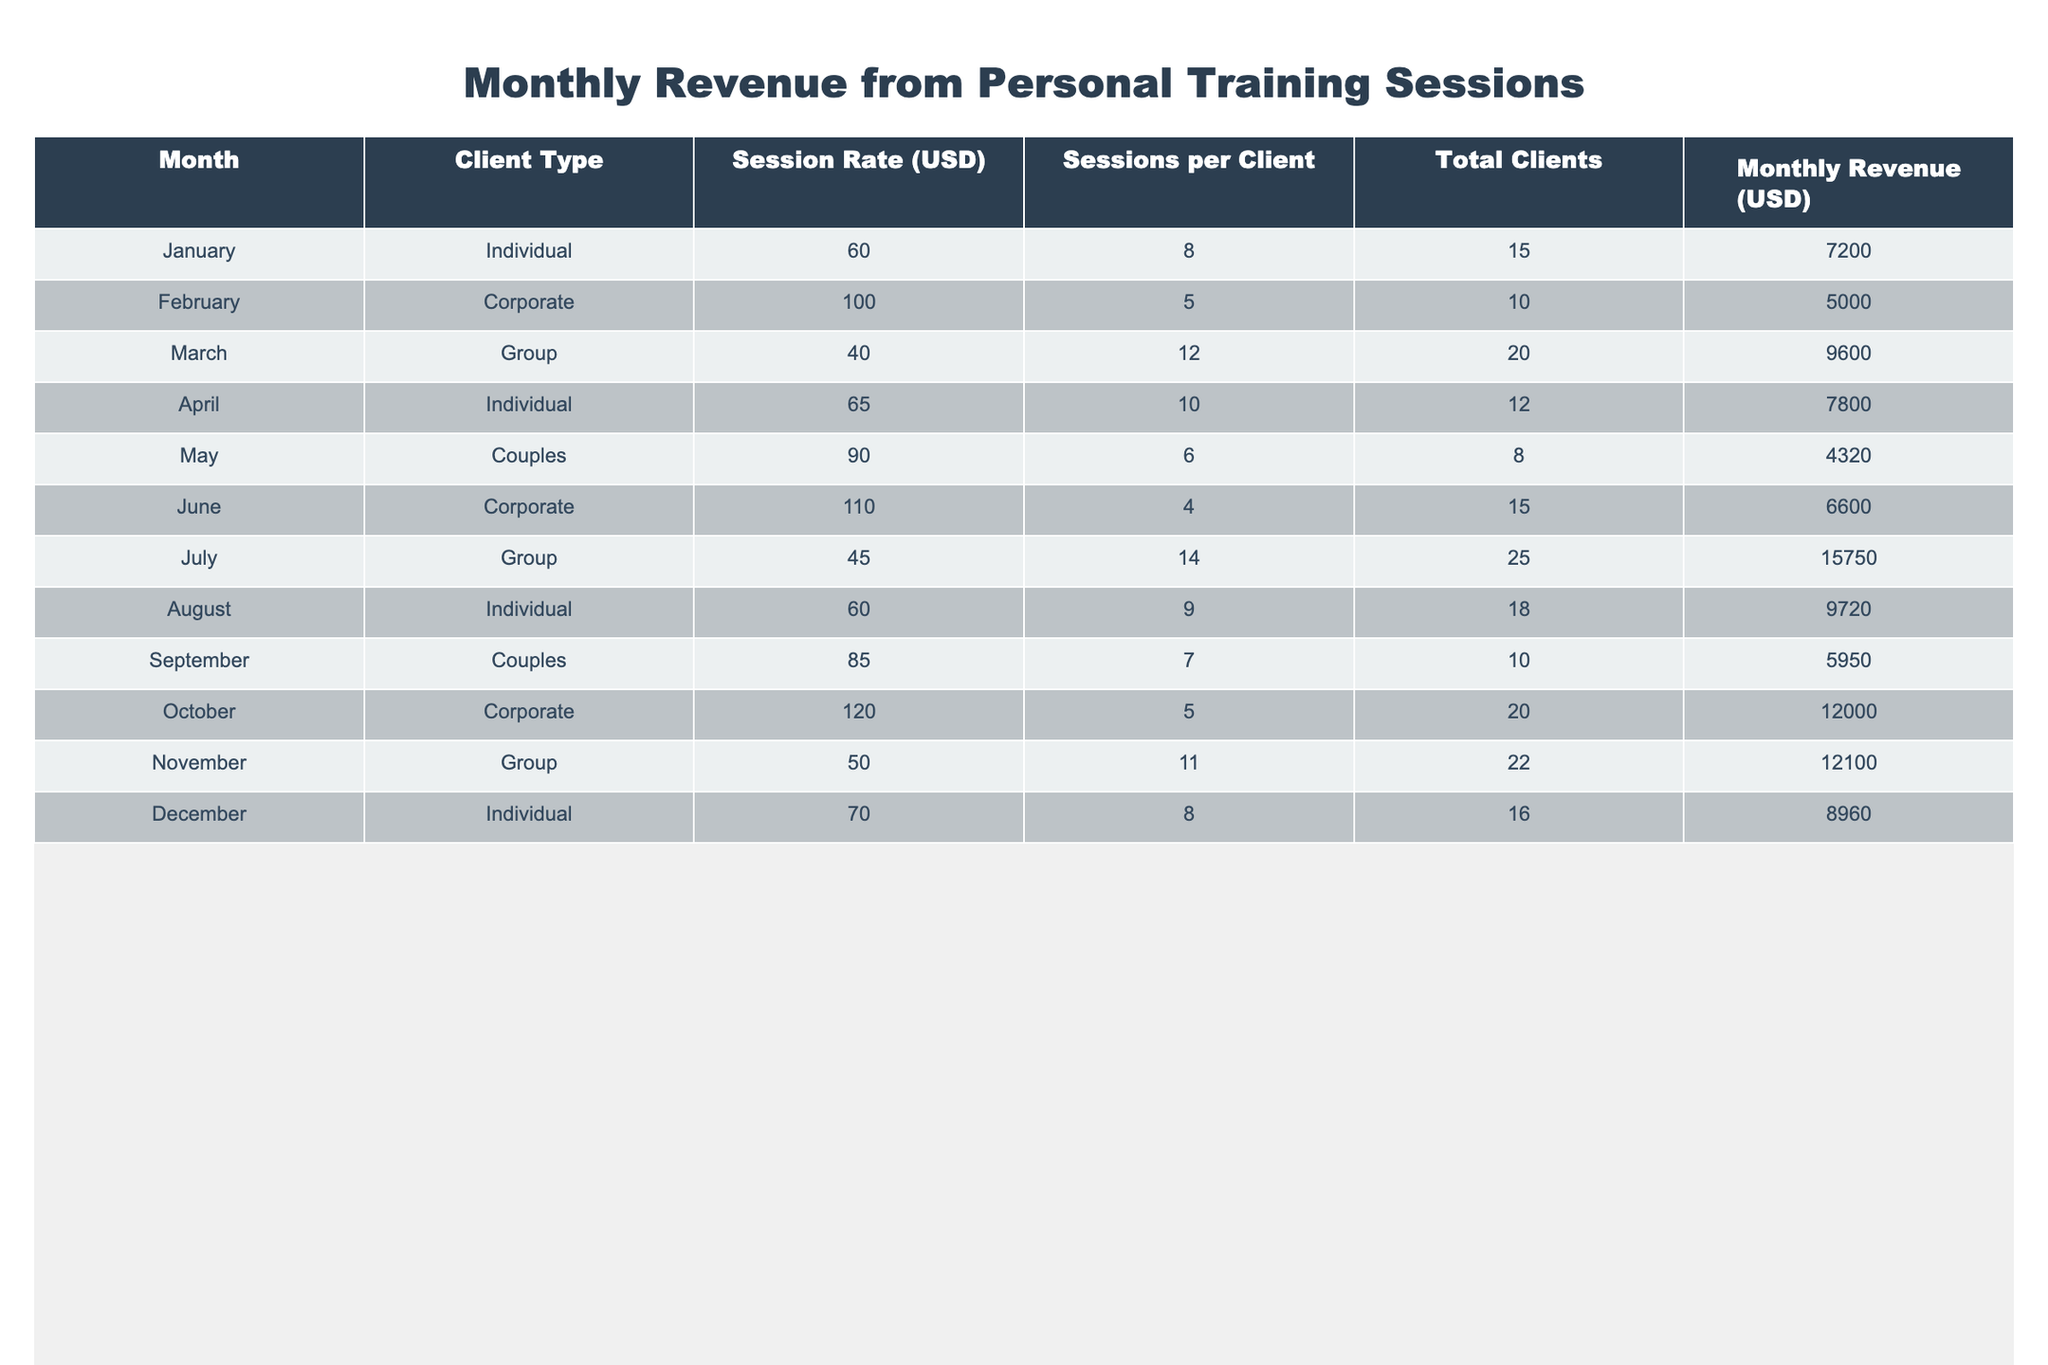What was the highest monthly revenue generated in the table? The highest monthly revenue can be found by looking through the "Monthly Revenue (USD)" column. The highest value there is 15750, which corresponds to July.
Answer: 15750 Which client type generated the least revenue in September? By checking the "Client Type" and "Monthly Revenue (USD)" columns, we find that "Couples" had the least revenue in September with 5950.
Answer: Couples What was the average session rate for Individual clients? To find the average session rate for Individual clients, we look at the "Session Rate (USD)" for Individual clients: 60, 65, 60, 70. Summing these rates gives us 255, and dividing by the number of entries (4) results in 63.75.
Answer: 63.75 Did Corporate clients generate more revenue in November than Individual clients in December? Looking at the table, Corporate clients generated 12000 in November while Individual clients generated 8960 in December. Since 12000 is greater than 8960, the statement is true.
Answer: Yes Calculate the total revenue generated from Group sessions across all months. To find the total revenue from Group sessions, we sum the revenues from the Group rows: 9600 (March) + 15750 (July) + 12100 (November) = 37450.
Answer: 37450 Which month had the highest session rate for Corporate clients? By checking the "Session Rate (USD)" for Corporate clients, we find that June has the highest session rate at 110.
Answer: June How many more total clients were there in July compared to January? Looking at the "Total Clients" column, we see that there were 25 clients in July and 15 clients in January. The difference is 25 - 15 = 10 clients.
Answer: 10 Is there any month where Individual clients had a higher session rate than Couples? The session rate for Individual clients are 60, 65, 60, and 70, while for Couples, the rates are 90 and 85. Since all Individual rates are lower than the Couples rates, the answer is no.
Answer: No What is the total revenue generated from Corporate clients in the table? By checking the relevant rows, the revenue generated from Corporate clients is 5000 (February) + 6600 (June) + 12000 (October) = 23600.
Answer: 23600 